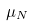<formula> <loc_0><loc_0><loc_500><loc_500>\mu _ { N }</formula> 